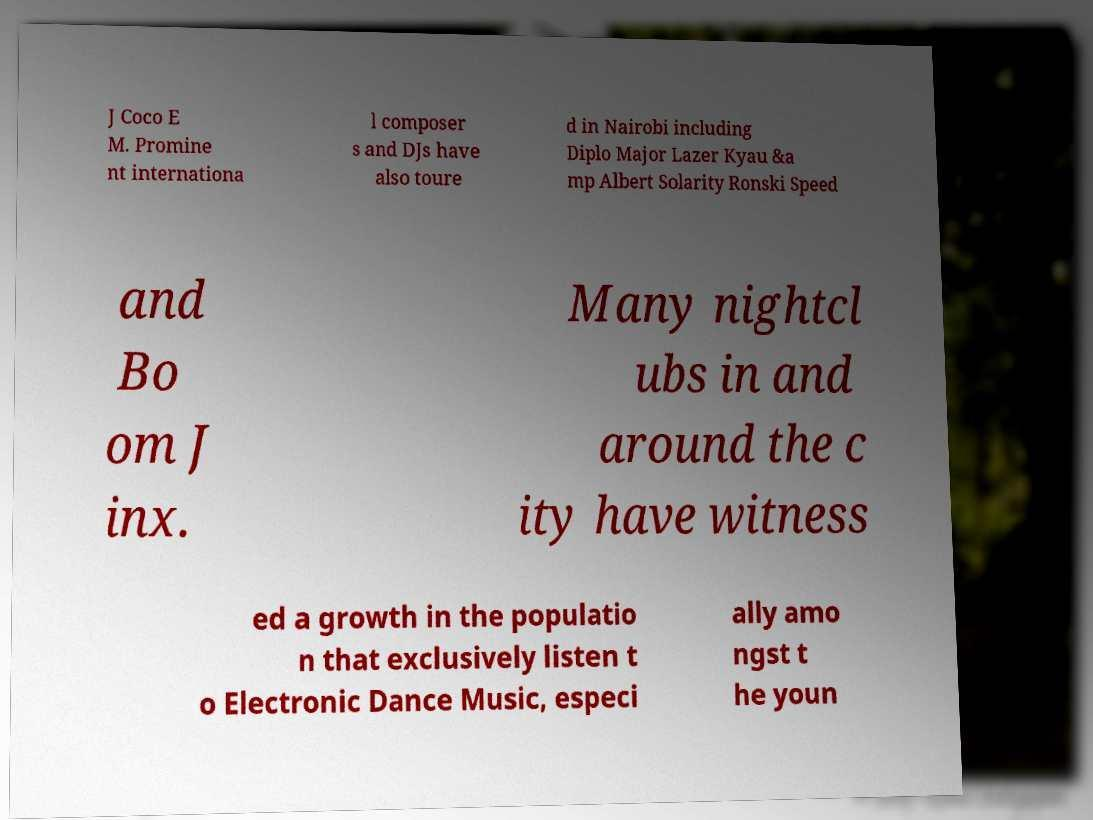I need the written content from this picture converted into text. Can you do that? J Coco E M. Promine nt internationa l composer s and DJs have also toure d in Nairobi including Diplo Major Lazer Kyau &a mp Albert Solarity Ronski Speed and Bo om J inx. Many nightcl ubs in and around the c ity have witness ed a growth in the populatio n that exclusively listen t o Electronic Dance Music, especi ally amo ngst t he youn 